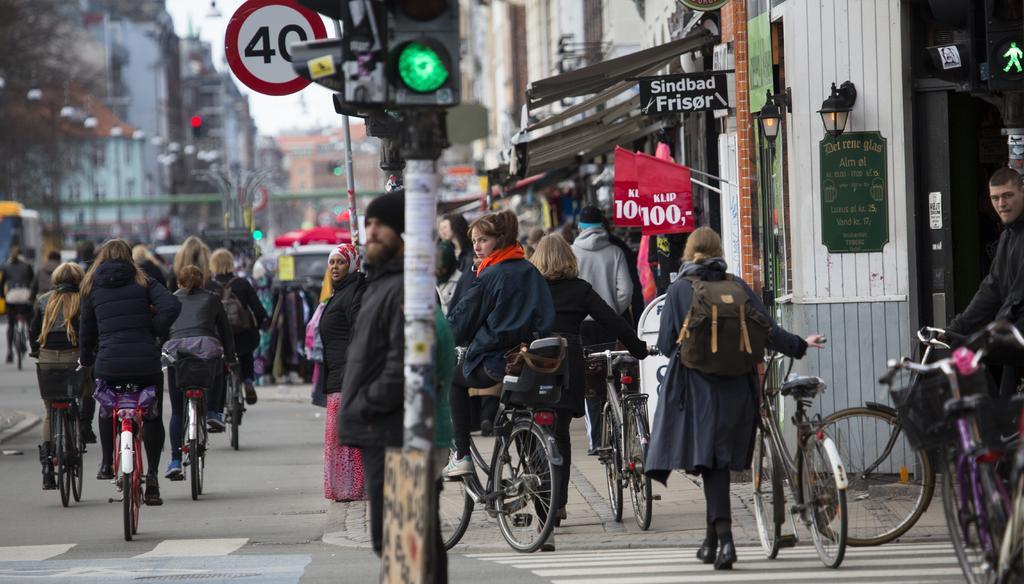How would you summarize this image in a sentence or two? In this image I can see the group of people riding the bicycle. And I can see a person standing at the signal pole. To the right there are some boards and the flags. In the background there is a building and the sky. 